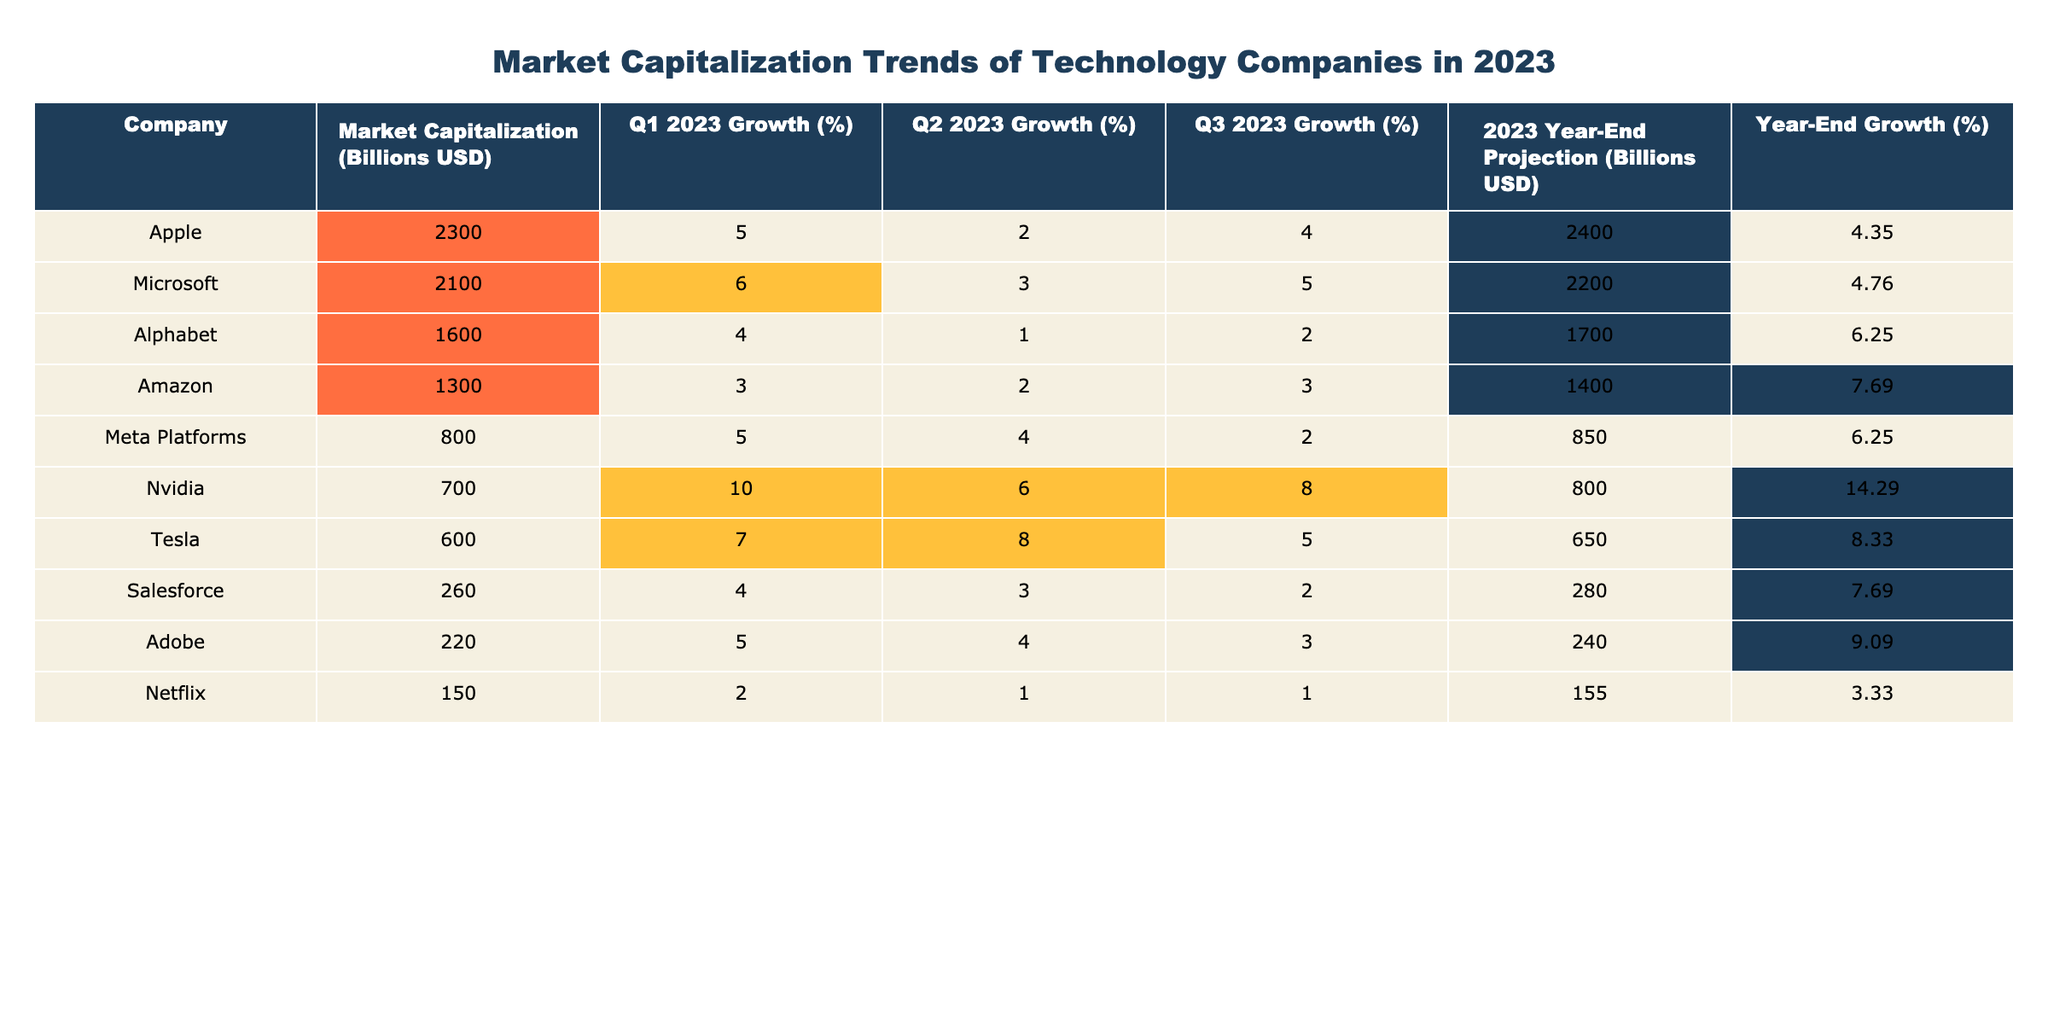What is the market capitalization of Apple in billions USD? The table lists Apple's market capitalization directly as 2300 billion USD.
Answer: 2300 billion USD Which company had the highest market capitalization in Q3 2023? The market capitalizations for Q3 2023 can be compared from the values in the table, and Apple has the highest market capitalization at 2300 billion USD.
Answer: Apple What was the year-end projection for Meta Platforms in billions USD? The year-end projection for Meta Platforms is shown in the table as 850 billion USD.
Answer: 850 billion USD Which company experienced the highest growth percentage in Q1 2023? By examining the Q1 2023 growth percentages, Nvidia has the highest growth rate of 10%.
Answer: Nvidia What is the average market capitalization of the listed companies? To find the average, sum the market capitalizations: 2300 + 2100 + 1600 + 1300 + 800 + 700 + 600 + 260 + 220 + 150 = 12000. Then divide by 10 (the number of companies) to get 1200 billion USD.
Answer: 1200 billion USD Did Tesla have a negative year-end growth percentage? The year-end growth percentage for Tesla is calculated as ((650 - 600) / 600) * 100 = 8.33%, which is not negative.
Answer: No Which company shows the most significant year-end growth projection percentage relative to its market capitalization? Calculate the year-end growth percentages for each company and identify the one with the highest value. Tesla’s calculation shows a growth of 8.33%, making it one of the significant gainers relative to its market cap.
Answer: Tesla How much market capitalization growth did Amazon project for the year-end in billions USD compared to its Q1 2023 starting point? Amazon started with 1300 billion USD in Q1 and projected 1400 billion USD for year-end, indicating a growth of 1400 - 1300 = 100 billion USD.
Answer: 100 billion USD Which company had consistent growth percentages across all quarters? By examining the growth percentages, Netflix has consistent low growth figures of 2%, 1%, and 1%, indicating limited variability.
Answer: Netflix If we consider the top three companies by market capitalization, what is their combined year-end projection? The year-end projections for the top three companies are Apple (2400 billion USD), Microsoft (2200 billion USD), and Alphabet (1700 billion USD). Their combined total is 2400 + 2200 + 1700 = 6300 billion USD.
Answer: 6300 billion USD 